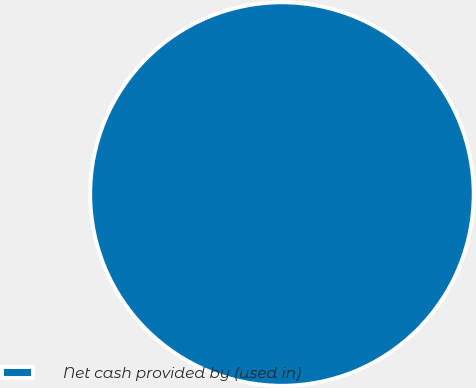Convert chart to OTSL. <chart><loc_0><loc_0><loc_500><loc_500><pie_chart><fcel>Net cash provided by (used in)<nl><fcel>100.0%<nl></chart> 